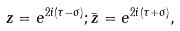Convert formula to latex. <formula><loc_0><loc_0><loc_500><loc_500>z = e ^ { 2 i ( \tau - \sigma ) } ; { \bar { z } } = e ^ { 2 i ( \tau + \sigma ) } ,</formula> 